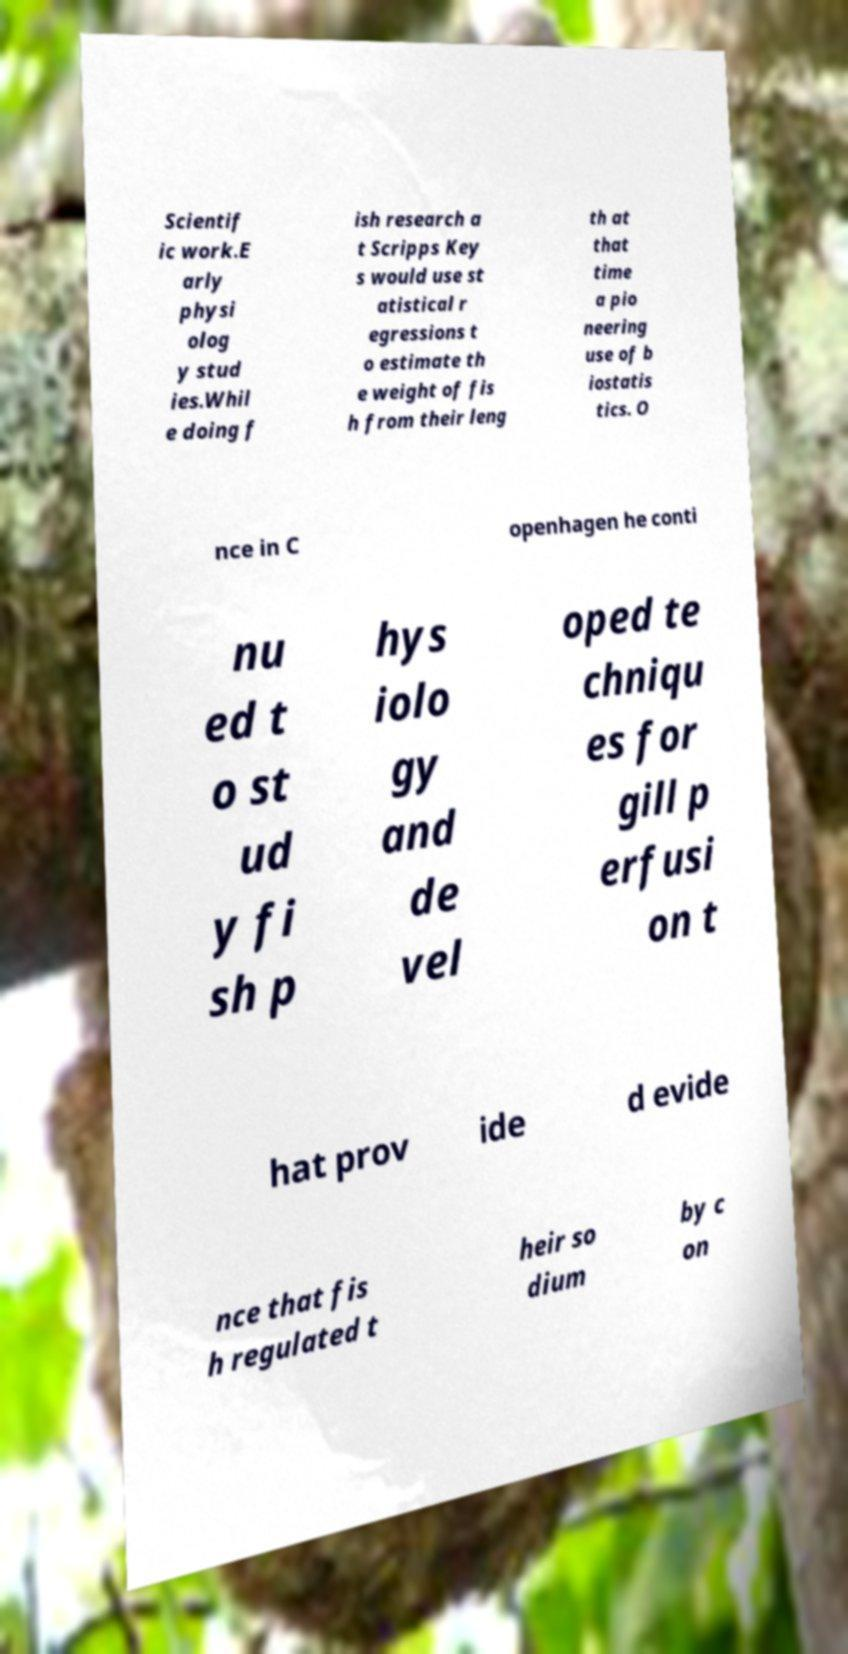There's text embedded in this image that I need extracted. Can you transcribe it verbatim? Scientif ic work.E arly physi olog y stud ies.Whil e doing f ish research a t Scripps Key s would use st atistical r egressions t o estimate th e weight of fis h from their leng th at that time a pio neering use of b iostatis tics. O nce in C openhagen he conti nu ed t o st ud y fi sh p hys iolo gy and de vel oped te chniqu es for gill p erfusi on t hat prov ide d evide nce that fis h regulated t heir so dium by c on 